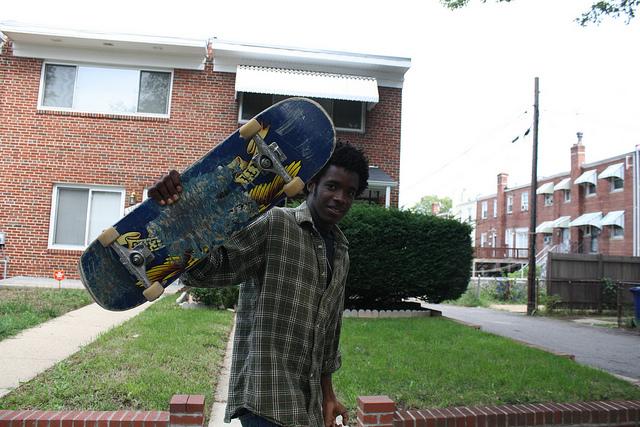Is he using the skateboard?
Short answer required. No. Is the ground wet?
Answer briefly. No. What is the person holding up?
Be succinct. Skateboard. 